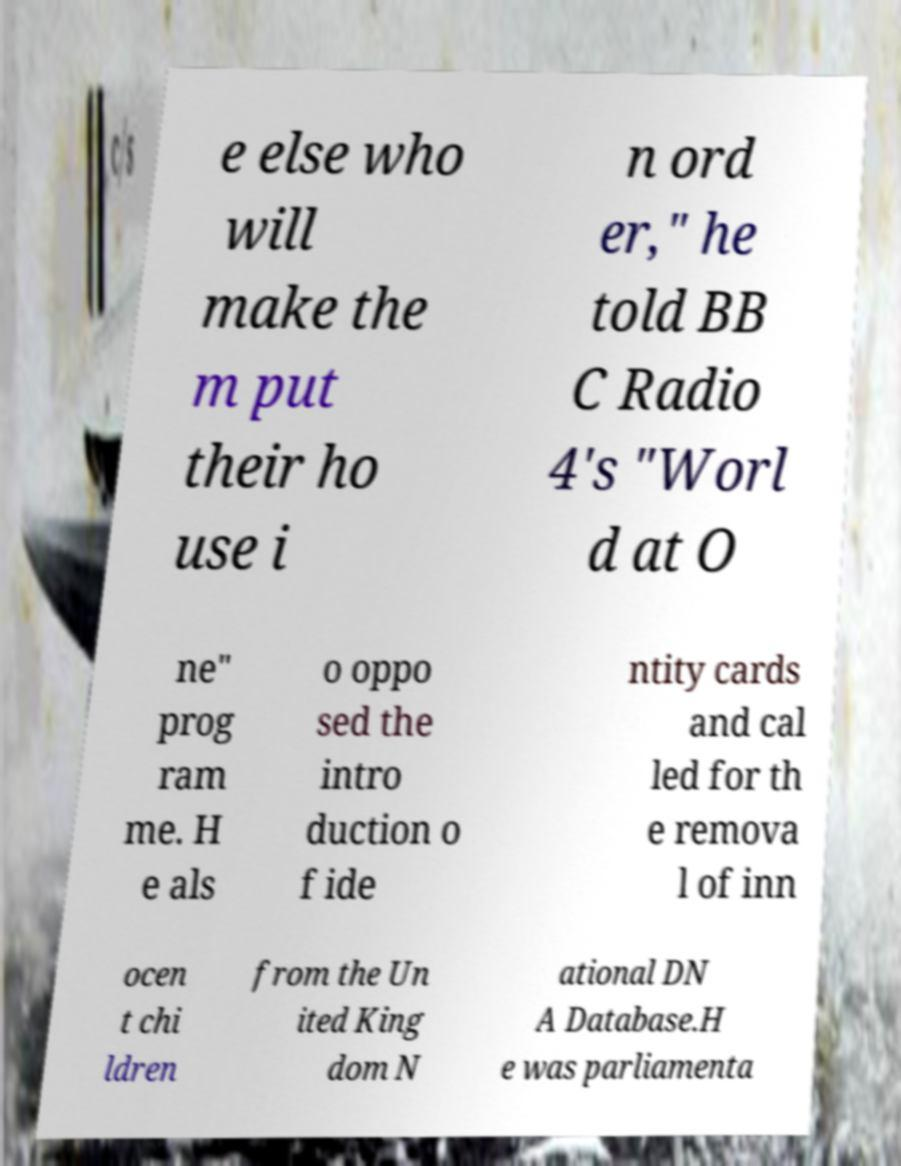Please identify and transcribe the text found in this image. e else who will make the m put their ho use i n ord er," he told BB C Radio 4's "Worl d at O ne" prog ram me. H e als o oppo sed the intro duction o f ide ntity cards and cal led for th e remova l of inn ocen t chi ldren from the Un ited King dom N ational DN A Database.H e was parliamenta 